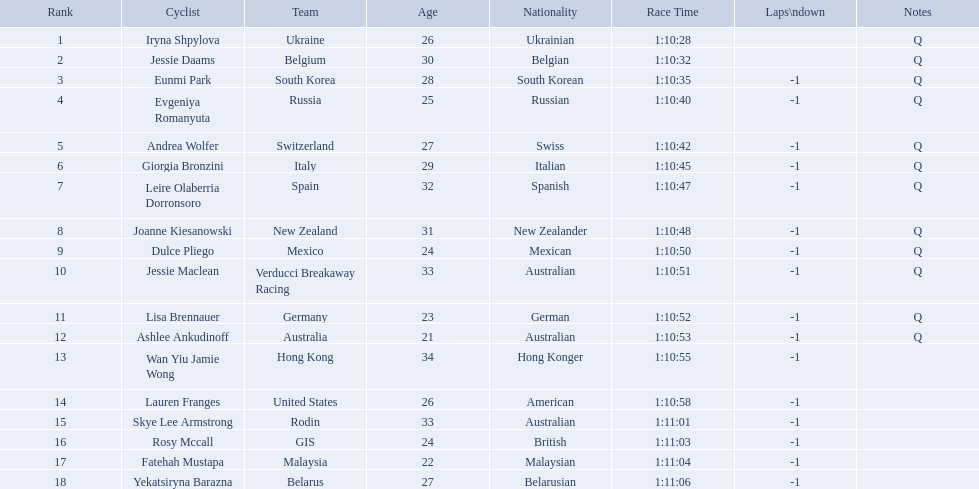Who competed in the race? Iryna Shpylova, Jessie Daams, Eunmi Park, Evgeniya Romanyuta, Andrea Wolfer, Giorgia Bronzini, Leire Olaberria Dorronsoro, Joanne Kiesanowski, Dulce Pliego, Jessie Maclean, Lisa Brennauer, Ashlee Ankudinoff, Wan Yiu Jamie Wong, Lauren Franges, Skye Lee Armstrong, Rosy Mccall, Fatehah Mustapa, Yekatsiryna Barazna. Who ranked highest in the race? Iryna Shpylova. 